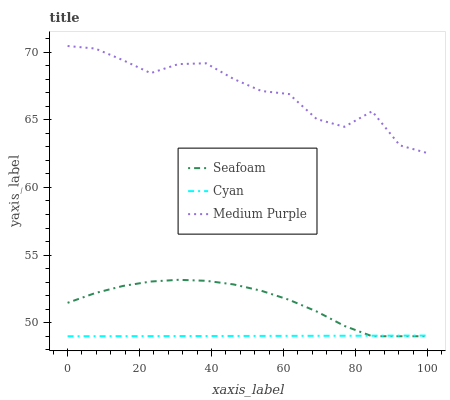Does Cyan have the minimum area under the curve?
Answer yes or no. Yes. Does Medium Purple have the maximum area under the curve?
Answer yes or no. Yes. Does Seafoam have the minimum area under the curve?
Answer yes or no. No. Does Seafoam have the maximum area under the curve?
Answer yes or no. No. Is Cyan the smoothest?
Answer yes or no. Yes. Is Medium Purple the roughest?
Answer yes or no. Yes. Is Seafoam the smoothest?
Answer yes or no. No. Is Seafoam the roughest?
Answer yes or no. No. Does Medium Purple have the highest value?
Answer yes or no. Yes. Does Seafoam have the highest value?
Answer yes or no. No. Is Cyan less than Medium Purple?
Answer yes or no. Yes. Is Medium Purple greater than Seafoam?
Answer yes or no. Yes. Does Cyan intersect Seafoam?
Answer yes or no. Yes. Is Cyan less than Seafoam?
Answer yes or no. No. Is Cyan greater than Seafoam?
Answer yes or no. No. Does Cyan intersect Medium Purple?
Answer yes or no. No. 